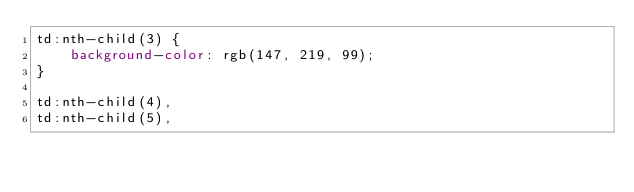Convert code to text. <code><loc_0><loc_0><loc_500><loc_500><_CSS_>td:nth-child(3) {
    background-color: rgb(147, 219, 99);
}

td:nth-child(4), 
td:nth-child(5),</code> 